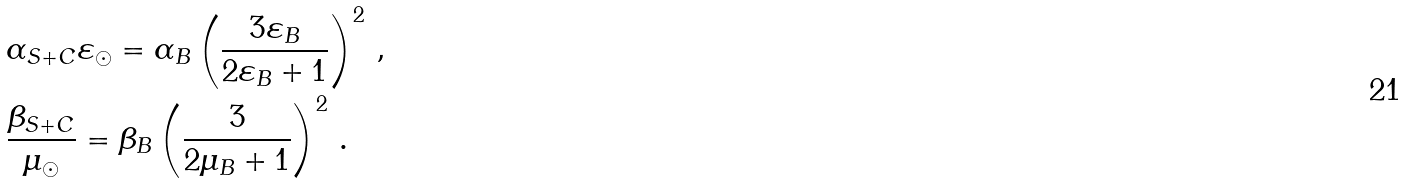<formula> <loc_0><loc_0><loc_500><loc_500>& \alpha _ { S + C } \varepsilon _ { \odot } = \alpha _ { B } \left ( \frac { 3 \varepsilon _ { B } } { 2 \varepsilon _ { B } + 1 } \right ) ^ { 2 } \, , \\ & \frac { \beta _ { S + C } } { \mu _ { \odot } } = \beta _ { B } \left ( \frac { 3 } { 2 \mu _ { B } + 1 } \right ) ^ { 2 } \, .</formula> 